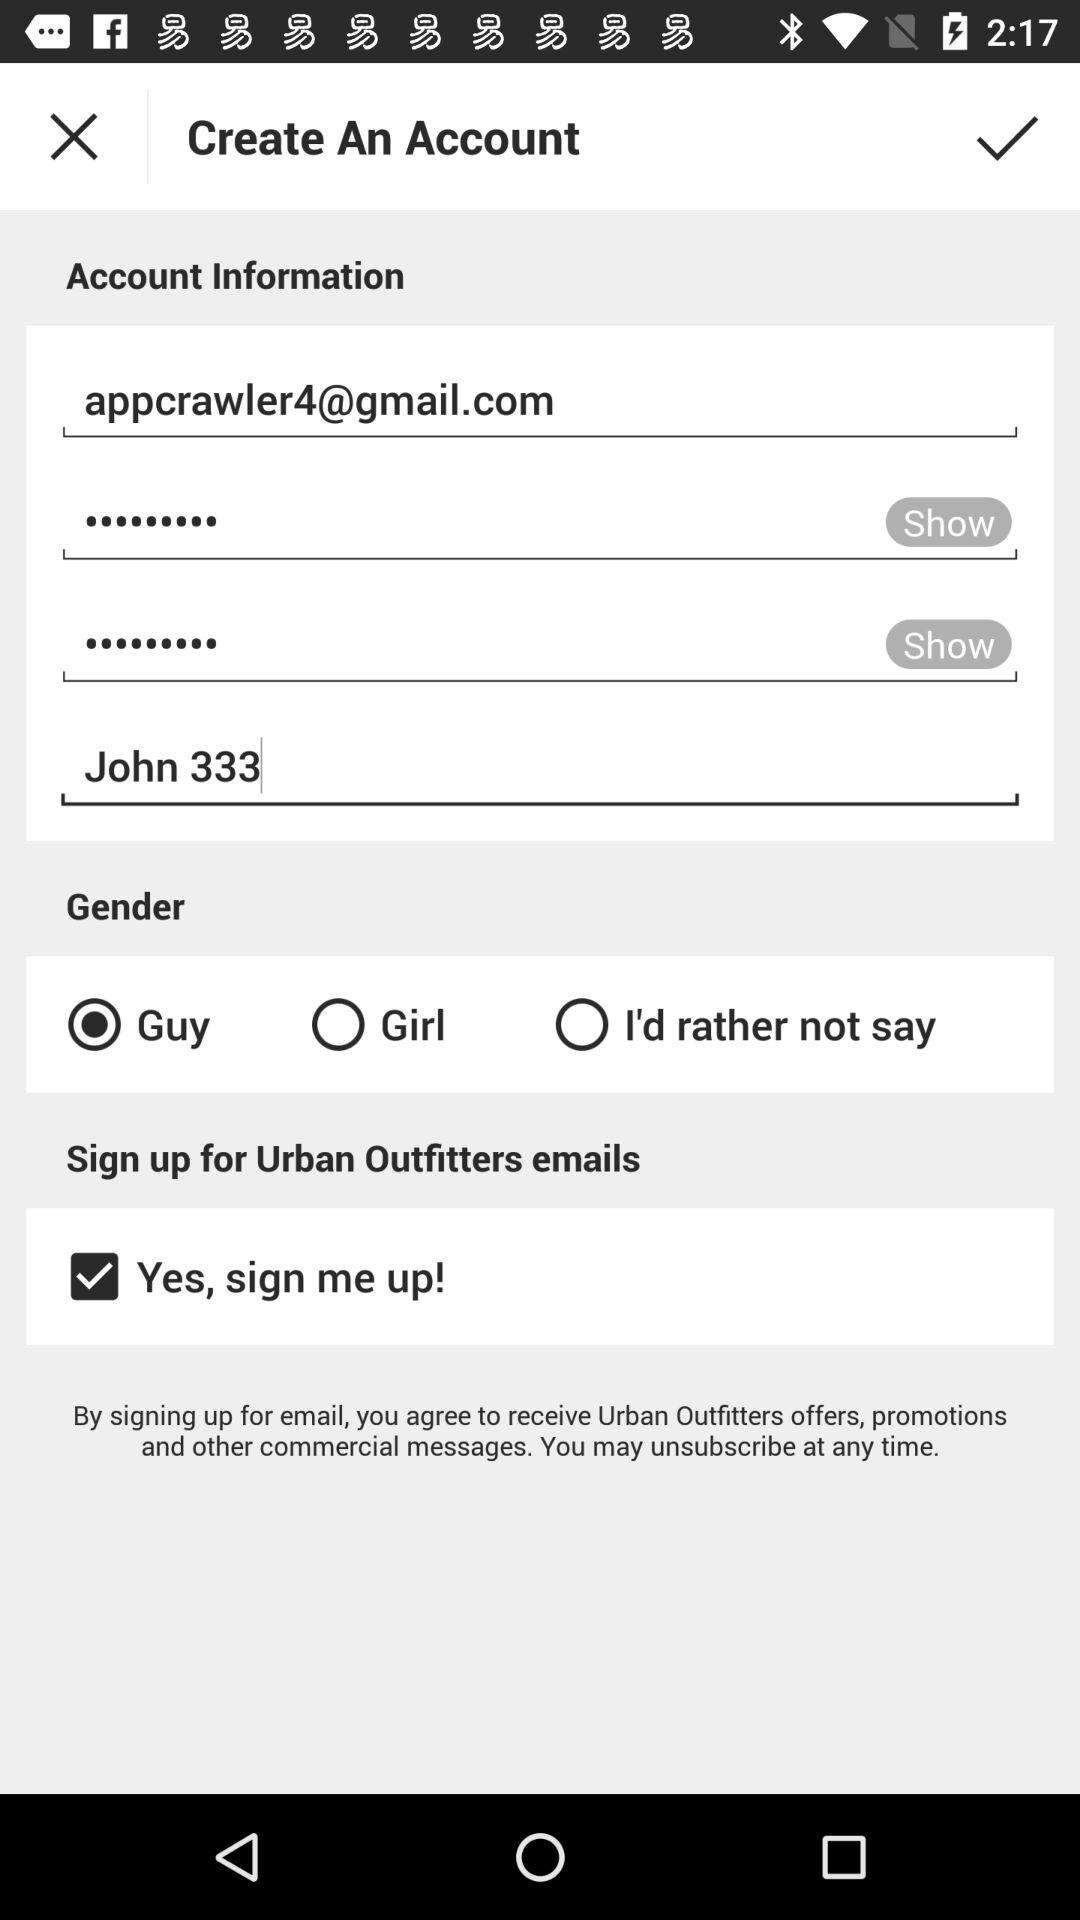What is a Gmail ID? The Gmail ID is appcrawler4@gmail.com. 